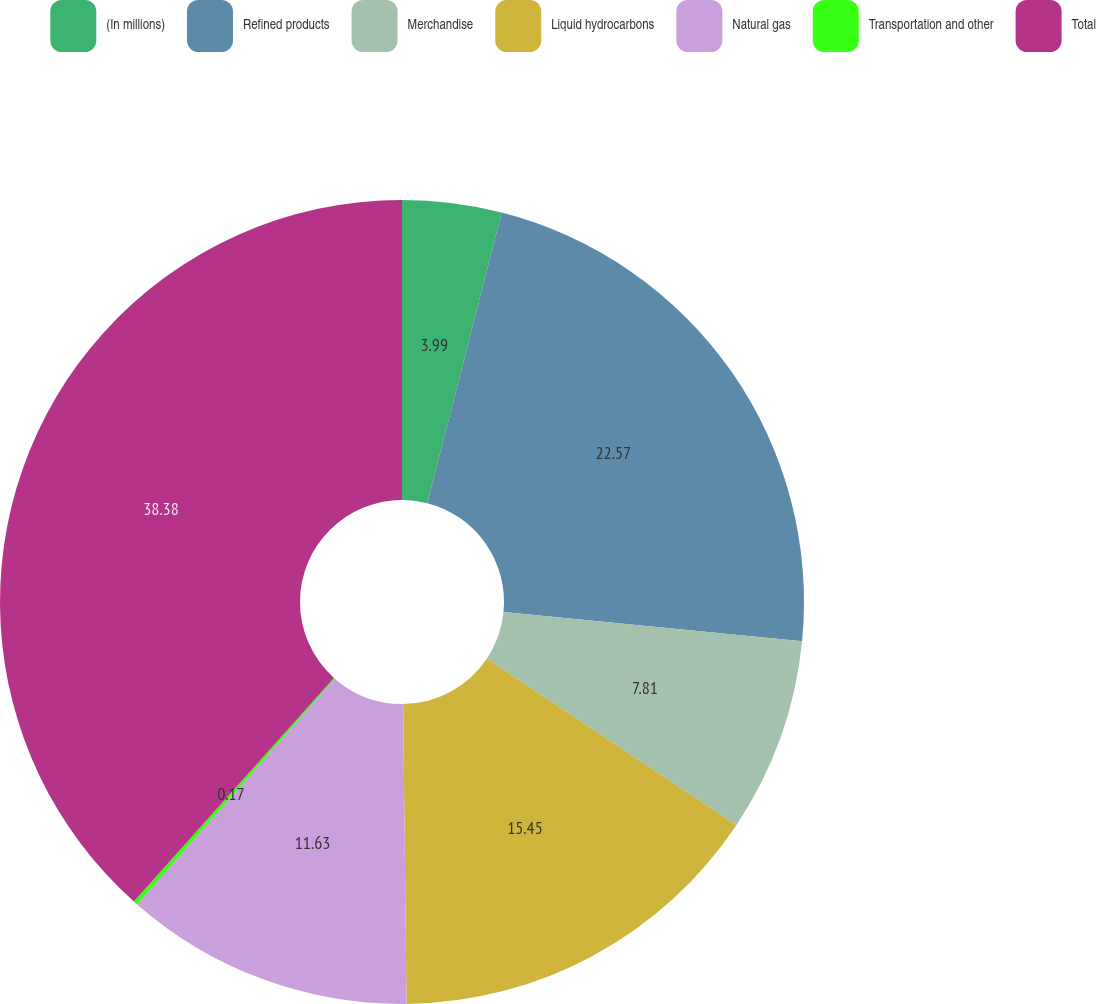Convert chart to OTSL. <chart><loc_0><loc_0><loc_500><loc_500><pie_chart><fcel>(In millions)<fcel>Refined products<fcel>Merchandise<fcel>Liquid hydrocarbons<fcel>Natural gas<fcel>Transportation and other<fcel>Total<nl><fcel>3.99%<fcel>22.57%<fcel>7.81%<fcel>15.45%<fcel>11.63%<fcel>0.17%<fcel>38.38%<nl></chart> 